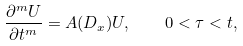<formula> <loc_0><loc_0><loc_500><loc_500>\frac { \partial ^ { m } U } { \partial t ^ { m } } = A ( D _ { x } ) U , \quad 0 < \tau < t ,</formula> 